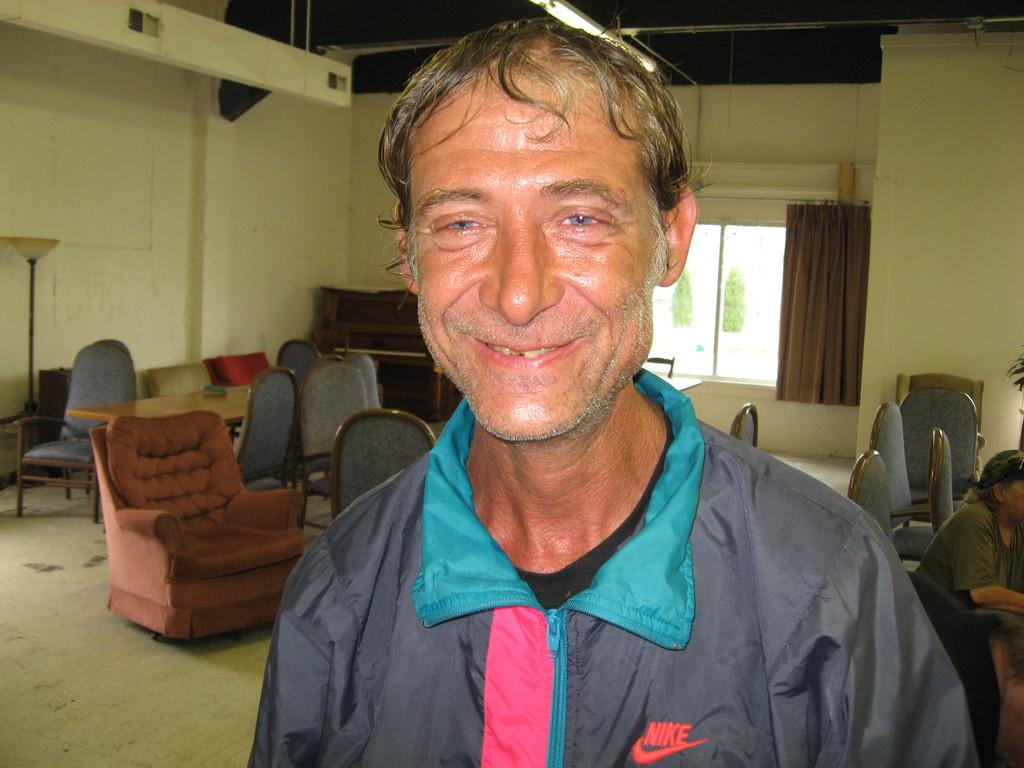What is the expression of the person in the image? The person in the image is smiling. What can be seen behind the smiling person? There are chairs behind the smiling person. Can you describe the person on the right side of the image? There is another person at the right side of the image. What is visible in the background of the image? There is a curtain and trees visible in the background of the image. What object is present at the left side of the image? There is a lamp stand at the left side of the image. Can you describe the monkey playing with a tub in the image? There is no monkey or tub present in the image. 